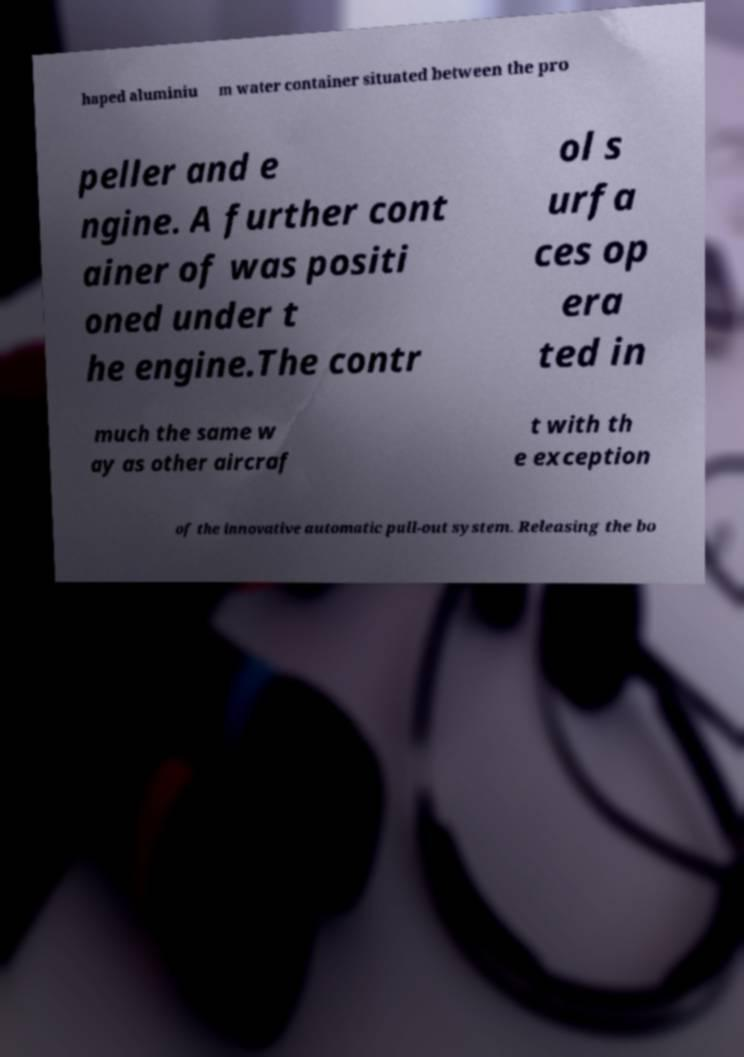What messages or text are displayed in this image? I need them in a readable, typed format. haped aluminiu m water container situated between the pro peller and e ngine. A further cont ainer of was positi oned under t he engine.The contr ol s urfa ces op era ted in much the same w ay as other aircraf t with th e exception of the innovative automatic pull-out system. Releasing the bo 